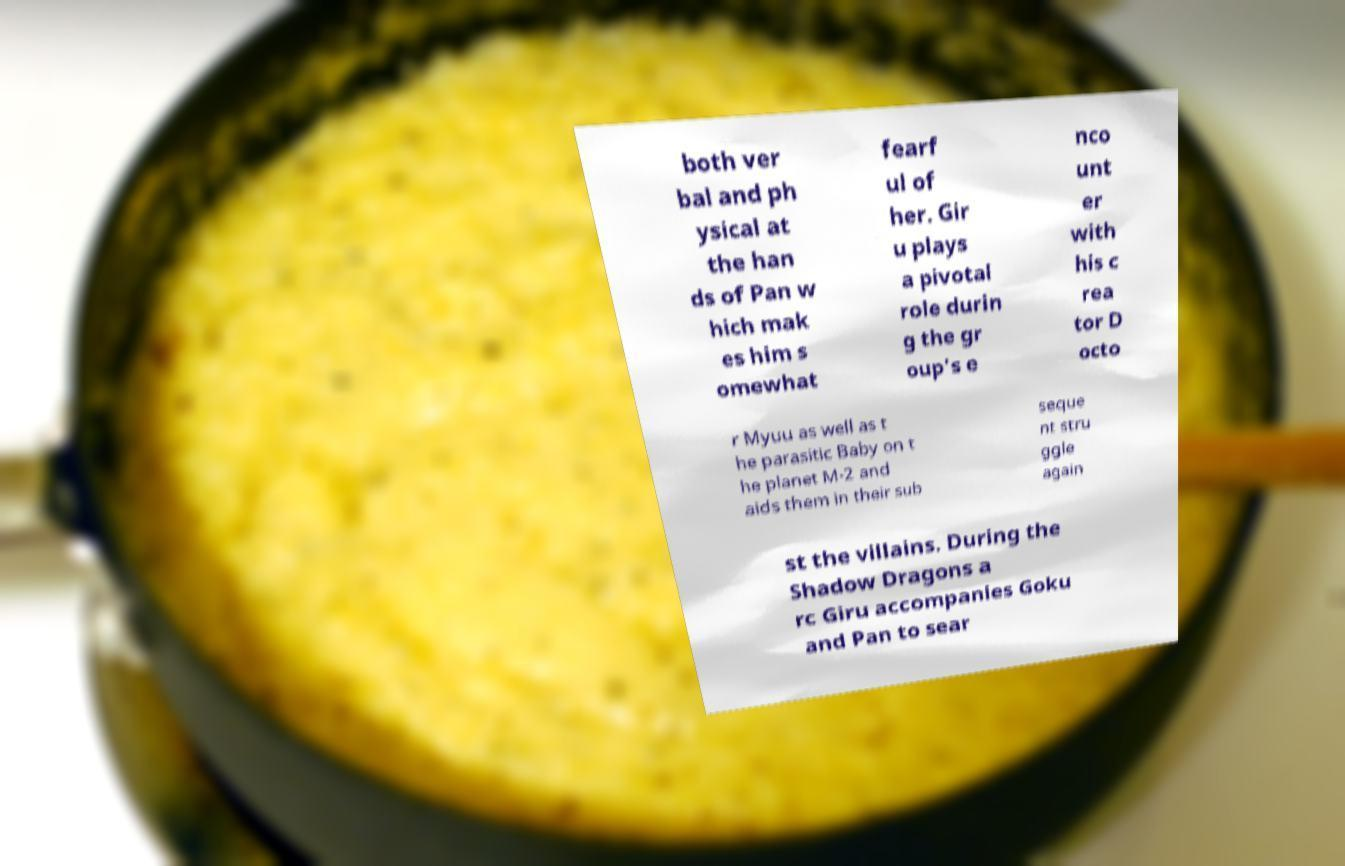Can you accurately transcribe the text from the provided image for me? both ver bal and ph ysical at the han ds of Pan w hich mak es him s omewhat fearf ul of her. Gir u plays a pivotal role durin g the gr oup's e nco unt er with his c rea tor D octo r Myuu as well as t he parasitic Baby on t he planet M-2 and aids them in their sub seque nt stru ggle again st the villains. During the Shadow Dragons a rc Giru accompanies Goku and Pan to sear 